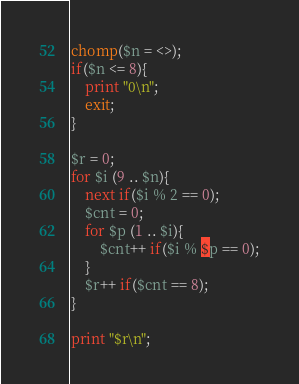Convert code to text. <code><loc_0><loc_0><loc_500><loc_500><_Perl_>chomp($n = <>);
if($n <= 8){
	print "0\n";
	exit;
}

$r = 0;
for $i (9 .. $n){
	next if($i % 2 == 0);
	$cnt = 0;
	for $p (1 .. $i){
		$cnt++ if($i % $p == 0);
	}
	$r++ if($cnt == 8);
}

print "$r\n";
</code> 